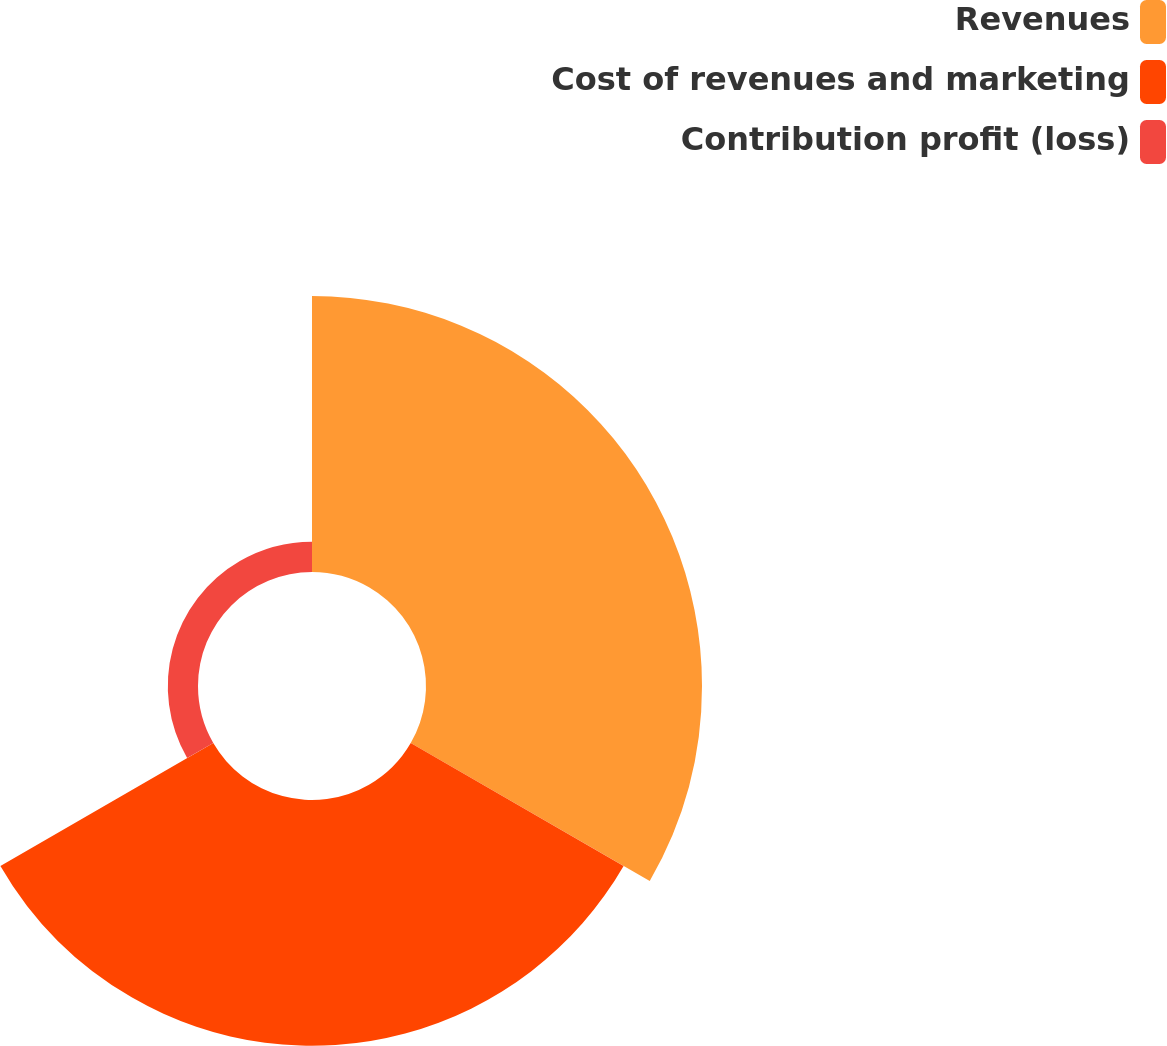Convert chart. <chart><loc_0><loc_0><loc_500><loc_500><pie_chart><fcel>Revenues<fcel>Cost of revenues and marketing<fcel>Contribution profit (loss)<nl><fcel>50.0%<fcel>44.53%<fcel>5.47%<nl></chart> 